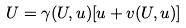Convert formula to latex. <formula><loc_0><loc_0><loc_500><loc_500>U = \gamma ( U , u ) [ u + v ( U , u ) ]</formula> 